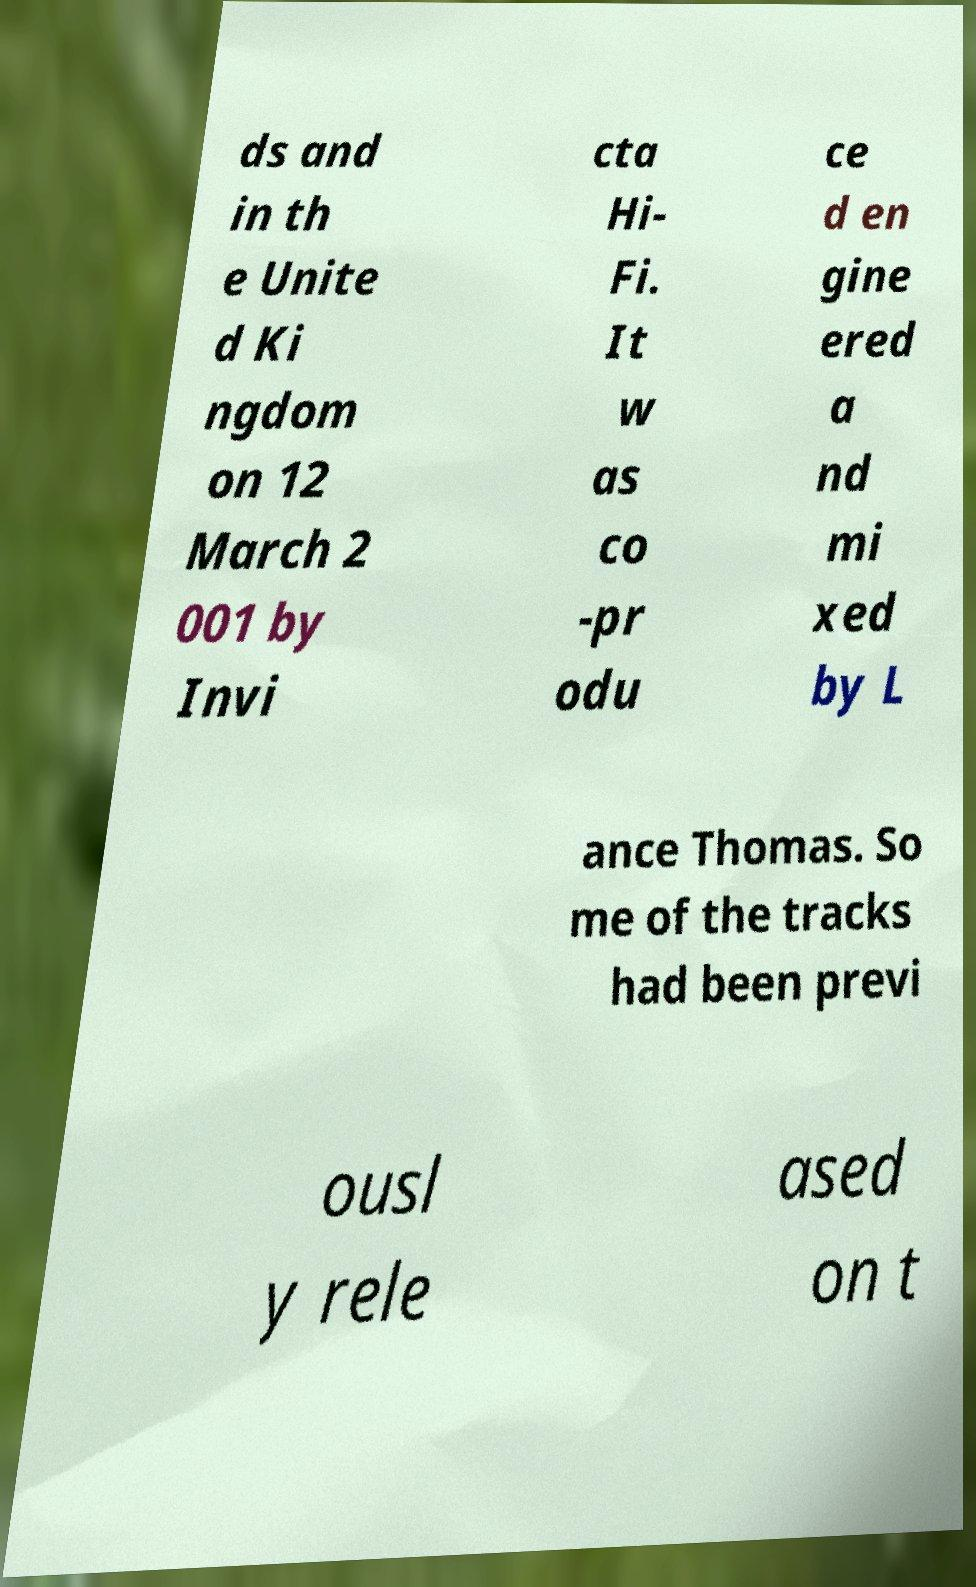I need the written content from this picture converted into text. Can you do that? ds and in th e Unite d Ki ngdom on 12 March 2 001 by Invi cta Hi- Fi. It w as co -pr odu ce d en gine ered a nd mi xed by L ance Thomas. So me of the tracks had been previ ousl y rele ased on t 